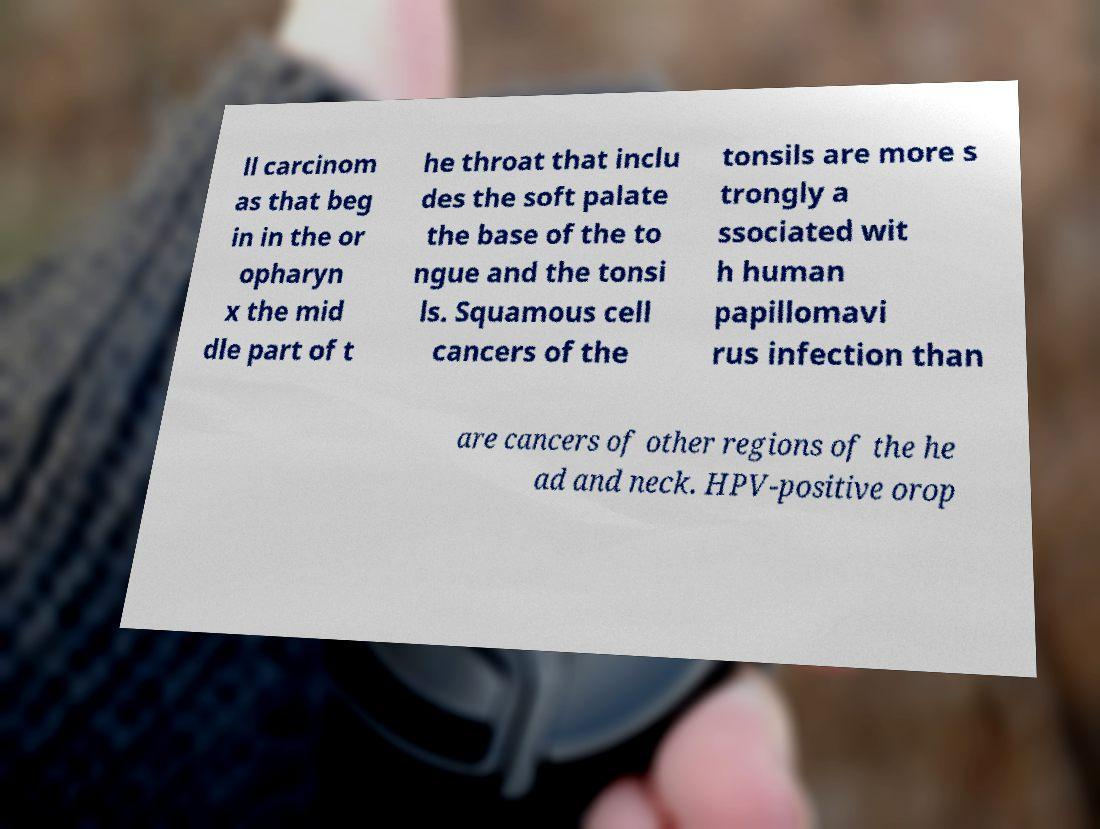There's text embedded in this image that I need extracted. Can you transcribe it verbatim? ll carcinom as that beg in in the or opharyn x the mid dle part of t he throat that inclu des the soft palate the base of the to ngue and the tonsi ls. Squamous cell cancers of the tonsils are more s trongly a ssociated wit h human papillomavi rus infection than are cancers of other regions of the he ad and neck. HPV-positive orop 